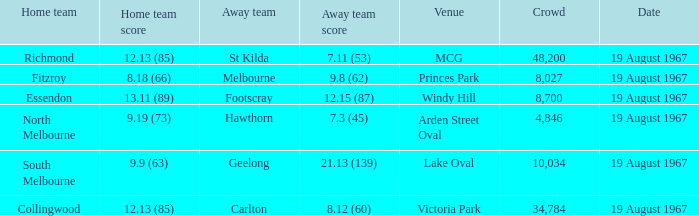What was the essendon home team's score? 13.11 (89). 